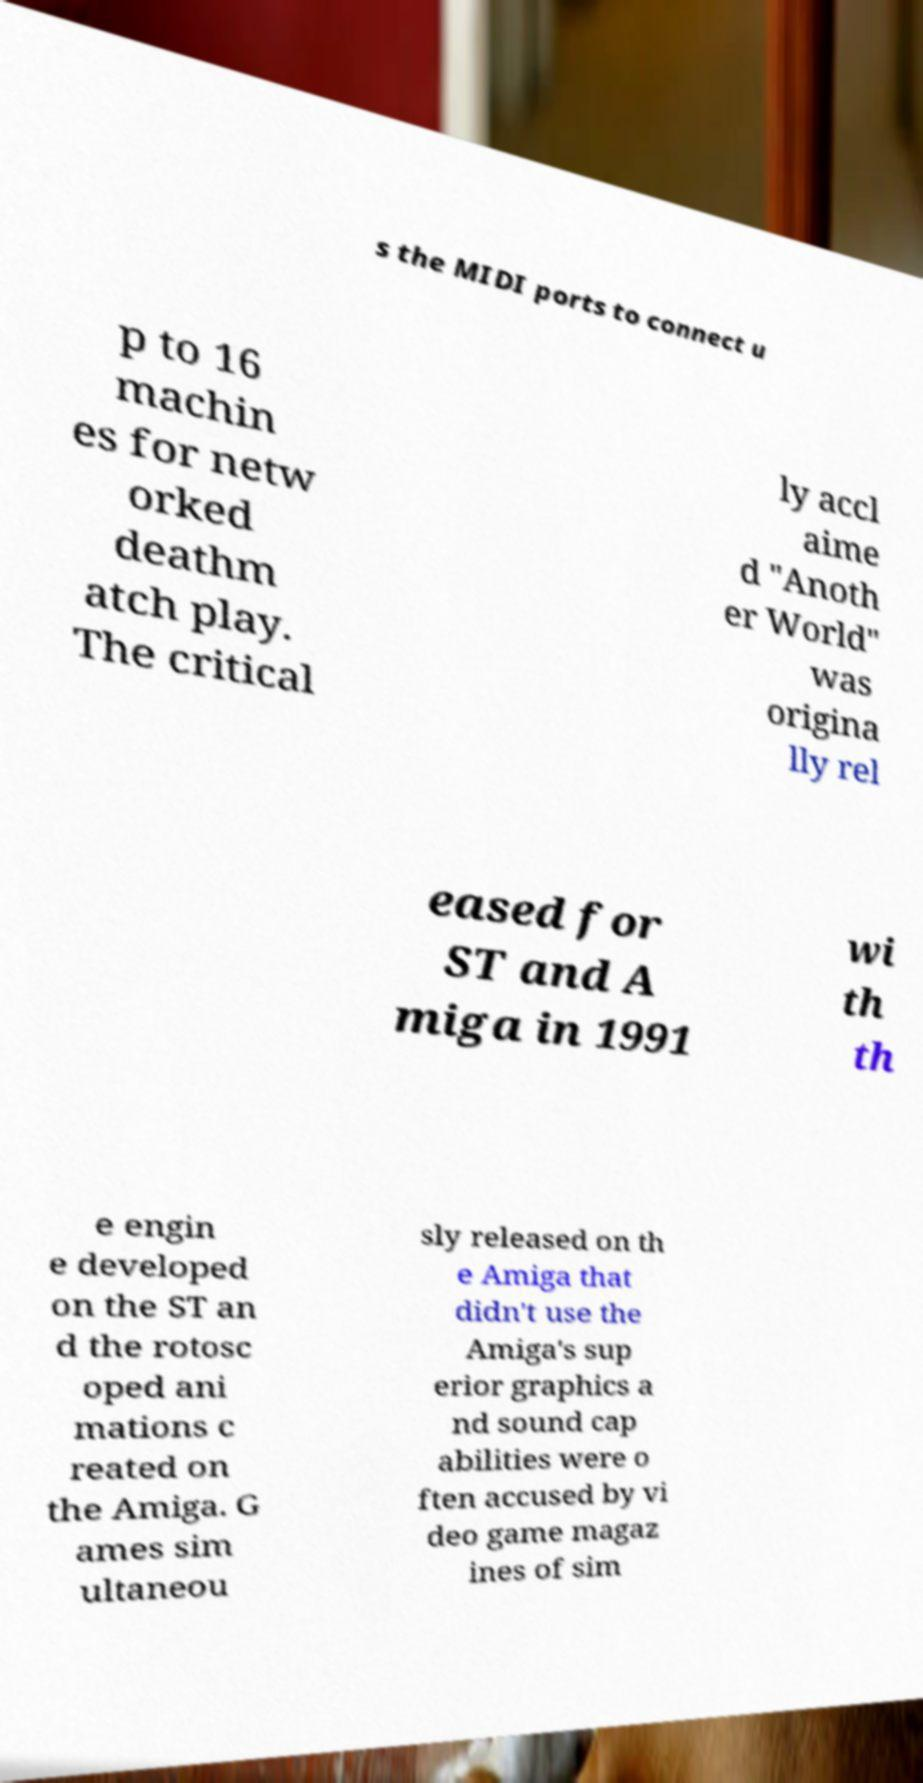What messages or text are displayed in this image? I need them in a readable, typed format. s the MIDI ports to connect u p to 16 machin es for netw orked deathm atch play. The critical ly accl aime d "Anoth er World" was origina lly rel eased for ST and A miga in 1991 wi th th e engin e developed on the ST an d the rotosc oped ani mations c reated on the Amiga. G ames sim ultaneou sly released on th e Amiga that didn't use the Amiga's sup erior graphics a nd sound cap abilities were o ften accused by vi deo game magaz ines of sim 